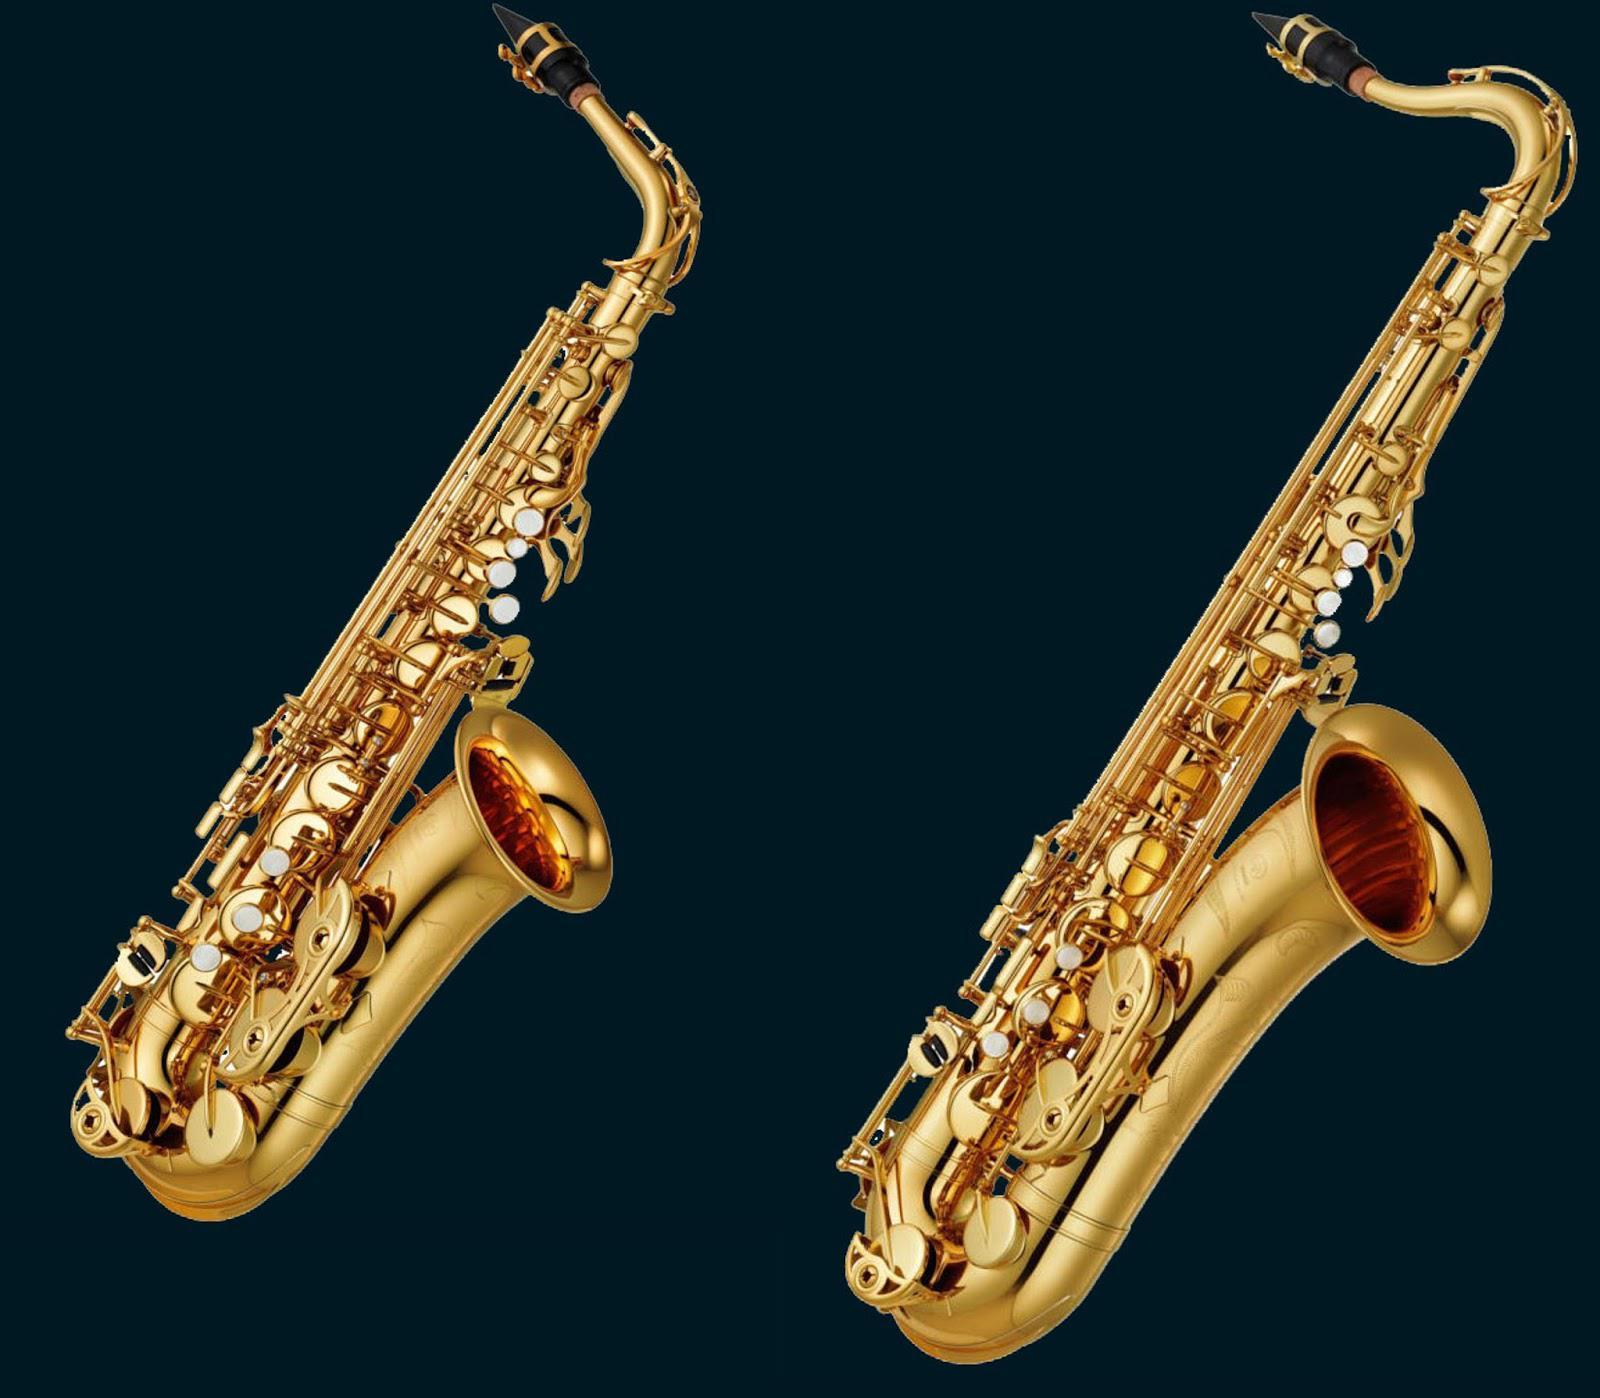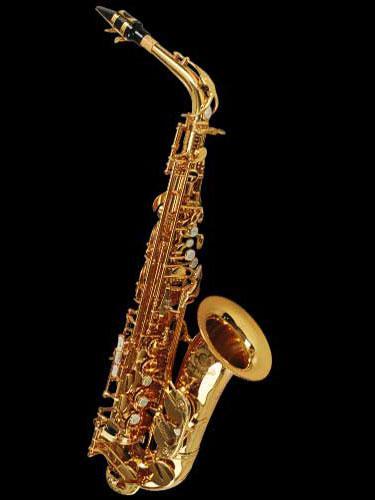The first image is the image on the left, the second image is the image on the right. Assess this claim about the two images: "Each saxophone is displayed with its bell facing rightward and its mouthpiece attached, but no saxophone is held by a person.". Correct or not? Answer yes or no. Yes. 